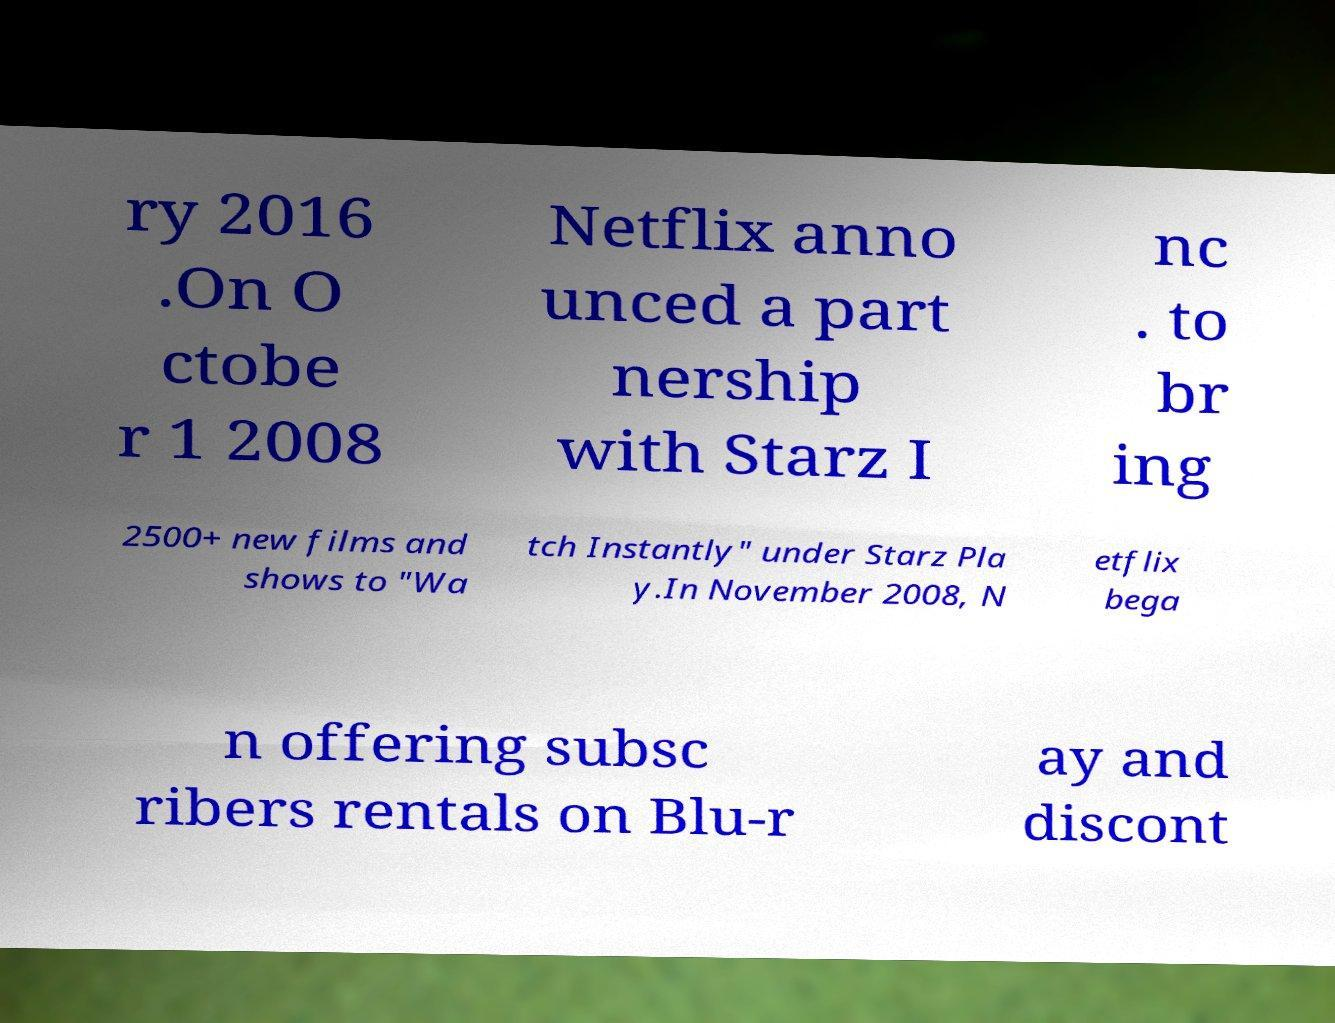There's text embedded in this image that I need extracted. Can you transcribe it verbatim? ry 2016 .On O ctobe r 1 2008 Netflix anno unced a part nership with Starz I nc . to br ing 2500+ new films and shows to "Wa tch Instantly" under Starz Pla y.In November 2008, N etflix bega n offering subsc ribers rentals on Blu-r ay and discont 